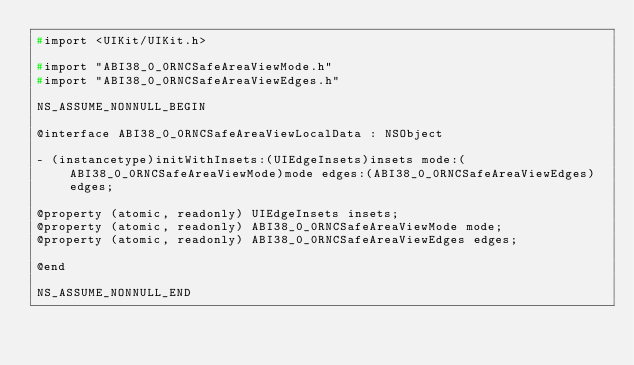Convert code to text. <code><loc_0><loc_0><loc_500><loc_500><_C_>#import <UIKit/UIKit.h>

#import "ABI38_0_0RNCSafeAreaViewMode.h"
#import "ABI38_0_0RNCSafeAreaViewEdges.h"

NS_ASSUME_NONNULL_BEGIN

@interface ABI38_0_0RNCSafeAreaViewLocalData : NSObject

- (instancetype)initWithInsets:(UIEdgeInsets)insets mode:(ABI38_0_0RNCSafeAreaViewMode)mode edges:(ABI38_0_0RNCSafeAreaViewEdges)edges;

@property (atomic, readonly) UIEdgeInsets insets;
@property (atomic, readonly) ABI38_0_0RNCSafeAreaViewMode mode;
@property (atomic, readonly) ABI38_0_0RNCSafeAreaViewEdges edges;

@end

NS_ASSUME_NONNULL_END
</code> 